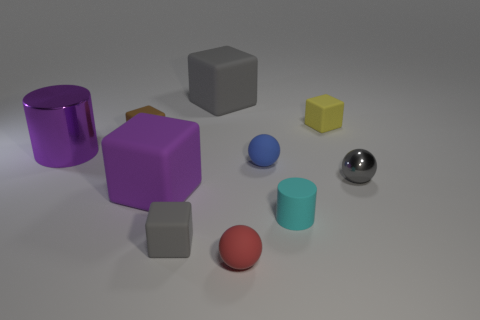Can you describe the texture of the objects in the image? Certainly! The objects appear to have various textures: the purple and red items have a smooth, matte finish, the yellow cube seems slightly rough, and the metal cylinder has a reflective, shiny surface. 